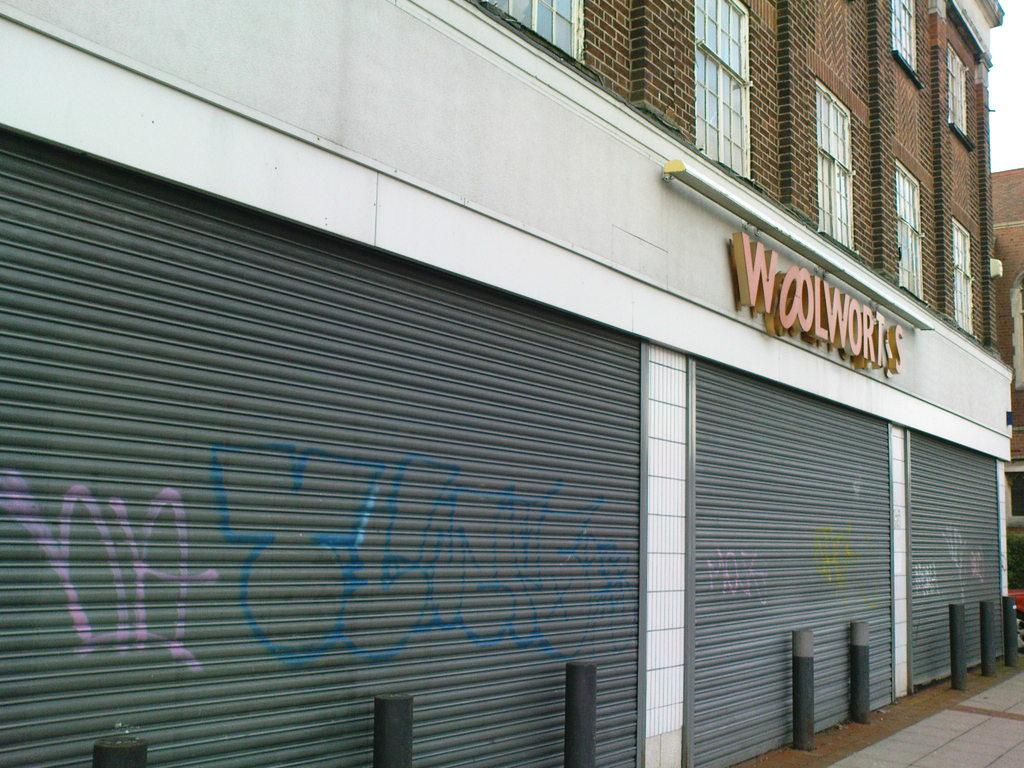What type of structures can be seen in the image? There are buildings in the image. What feature can be observed on some of the buildings? There are shutters in the image. What object is present in the image? There is a board in the image. What can be seen in the background of the image? The sky is visible in the background of the image. What type of attraction is being held in the image? There is no indication of an attraction being held in the image. What is the income of the person in the image? There is no person present in the image, so their income cannot be determined. 